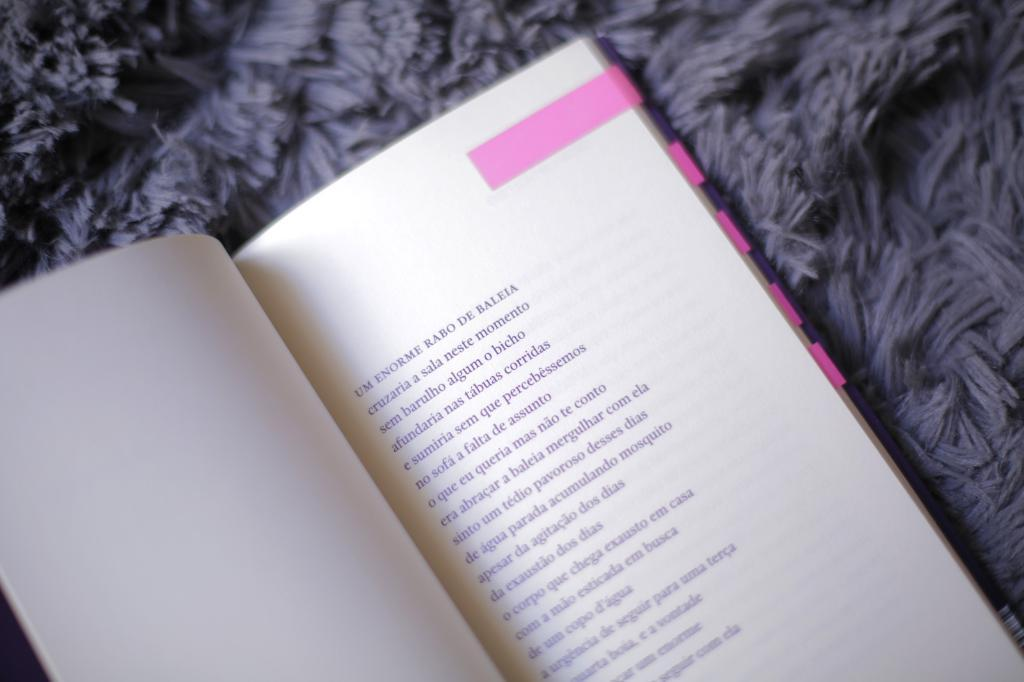What is the main object in the image? There is a book with text in the image. What is placed on top of the book? There is a mat on top of the book. What type of building can be seen in the background of the image? There is no building visible in the image; it only features a book with a mat on top. What sense is being stimulated by the book in the image? The image does not provide information about which sense is being stimulated by the book. 